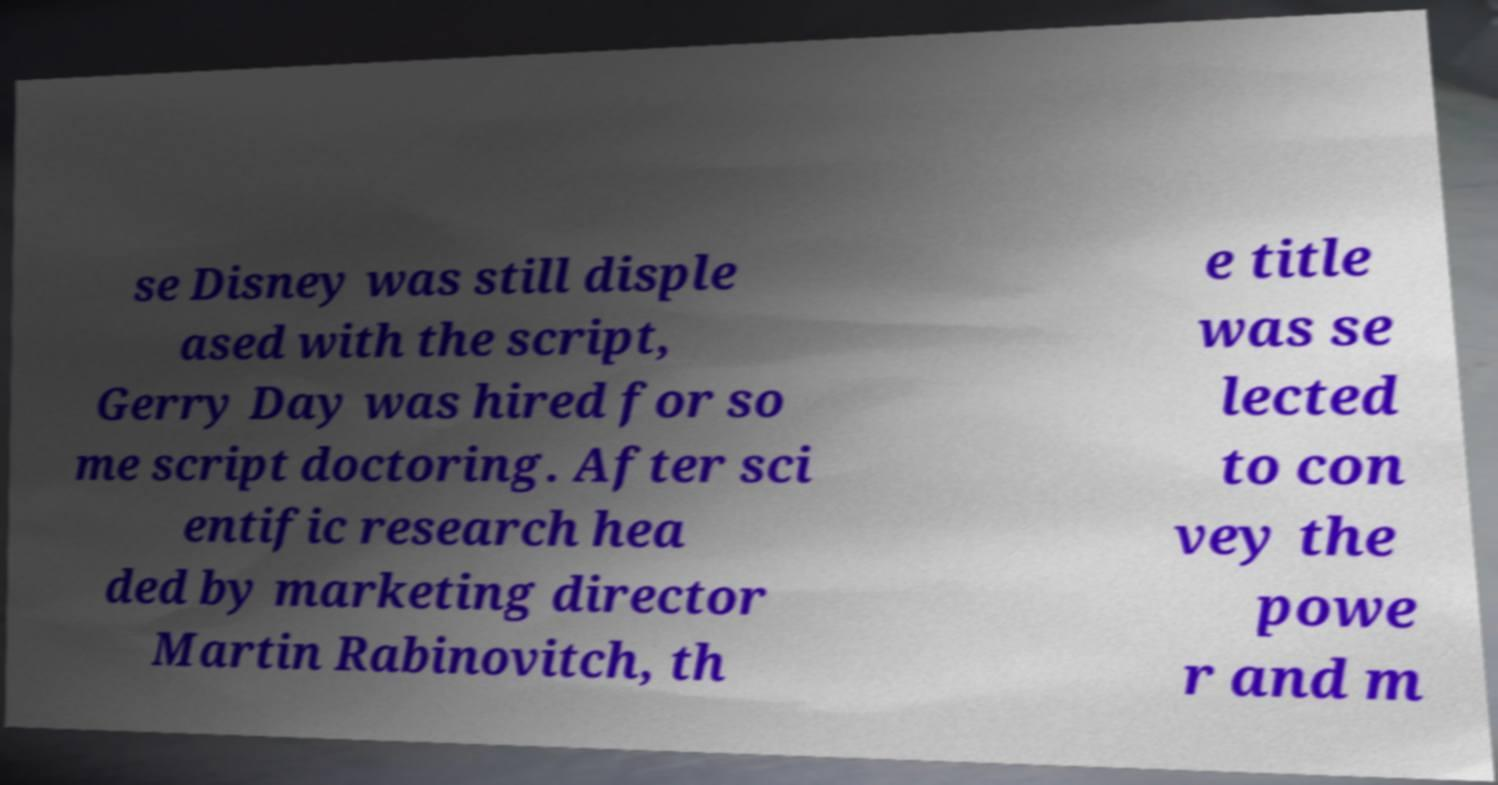Please identify and transcribe the text found in this image. se Disney was still disple ased with the script, Gerry Day was hired for so me script doctoring. After sci entific research hea ded by marketing director Martin Rabinovitch, th e title was se lected to con vey the powe r and m 